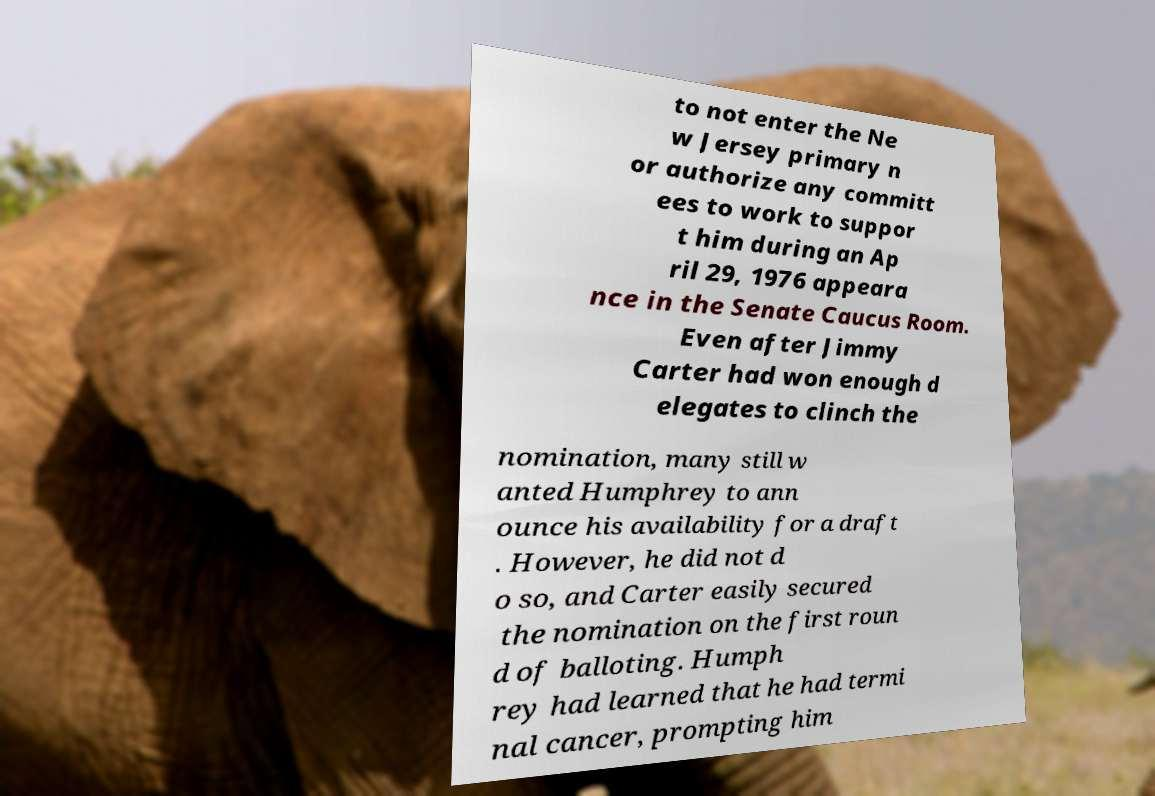Can you accurately transcribe the text from the provided image for me? to not enter the Ne w Jersey primary n or authorize any committ ees to work to suppor t him during an Ap ril 29, 1976 appeara nce in the Senate Caucus Room. Even after Jimmy Carter had won enough d elegates to clinch the nomination, many still w anted Humphrey to ann ounce his availability for a draft . However, he did not d o so, and Carter easily secured the nomination on the first roun d of balloting. Humph rey had learned that he had termi nal cancer, prompting him 